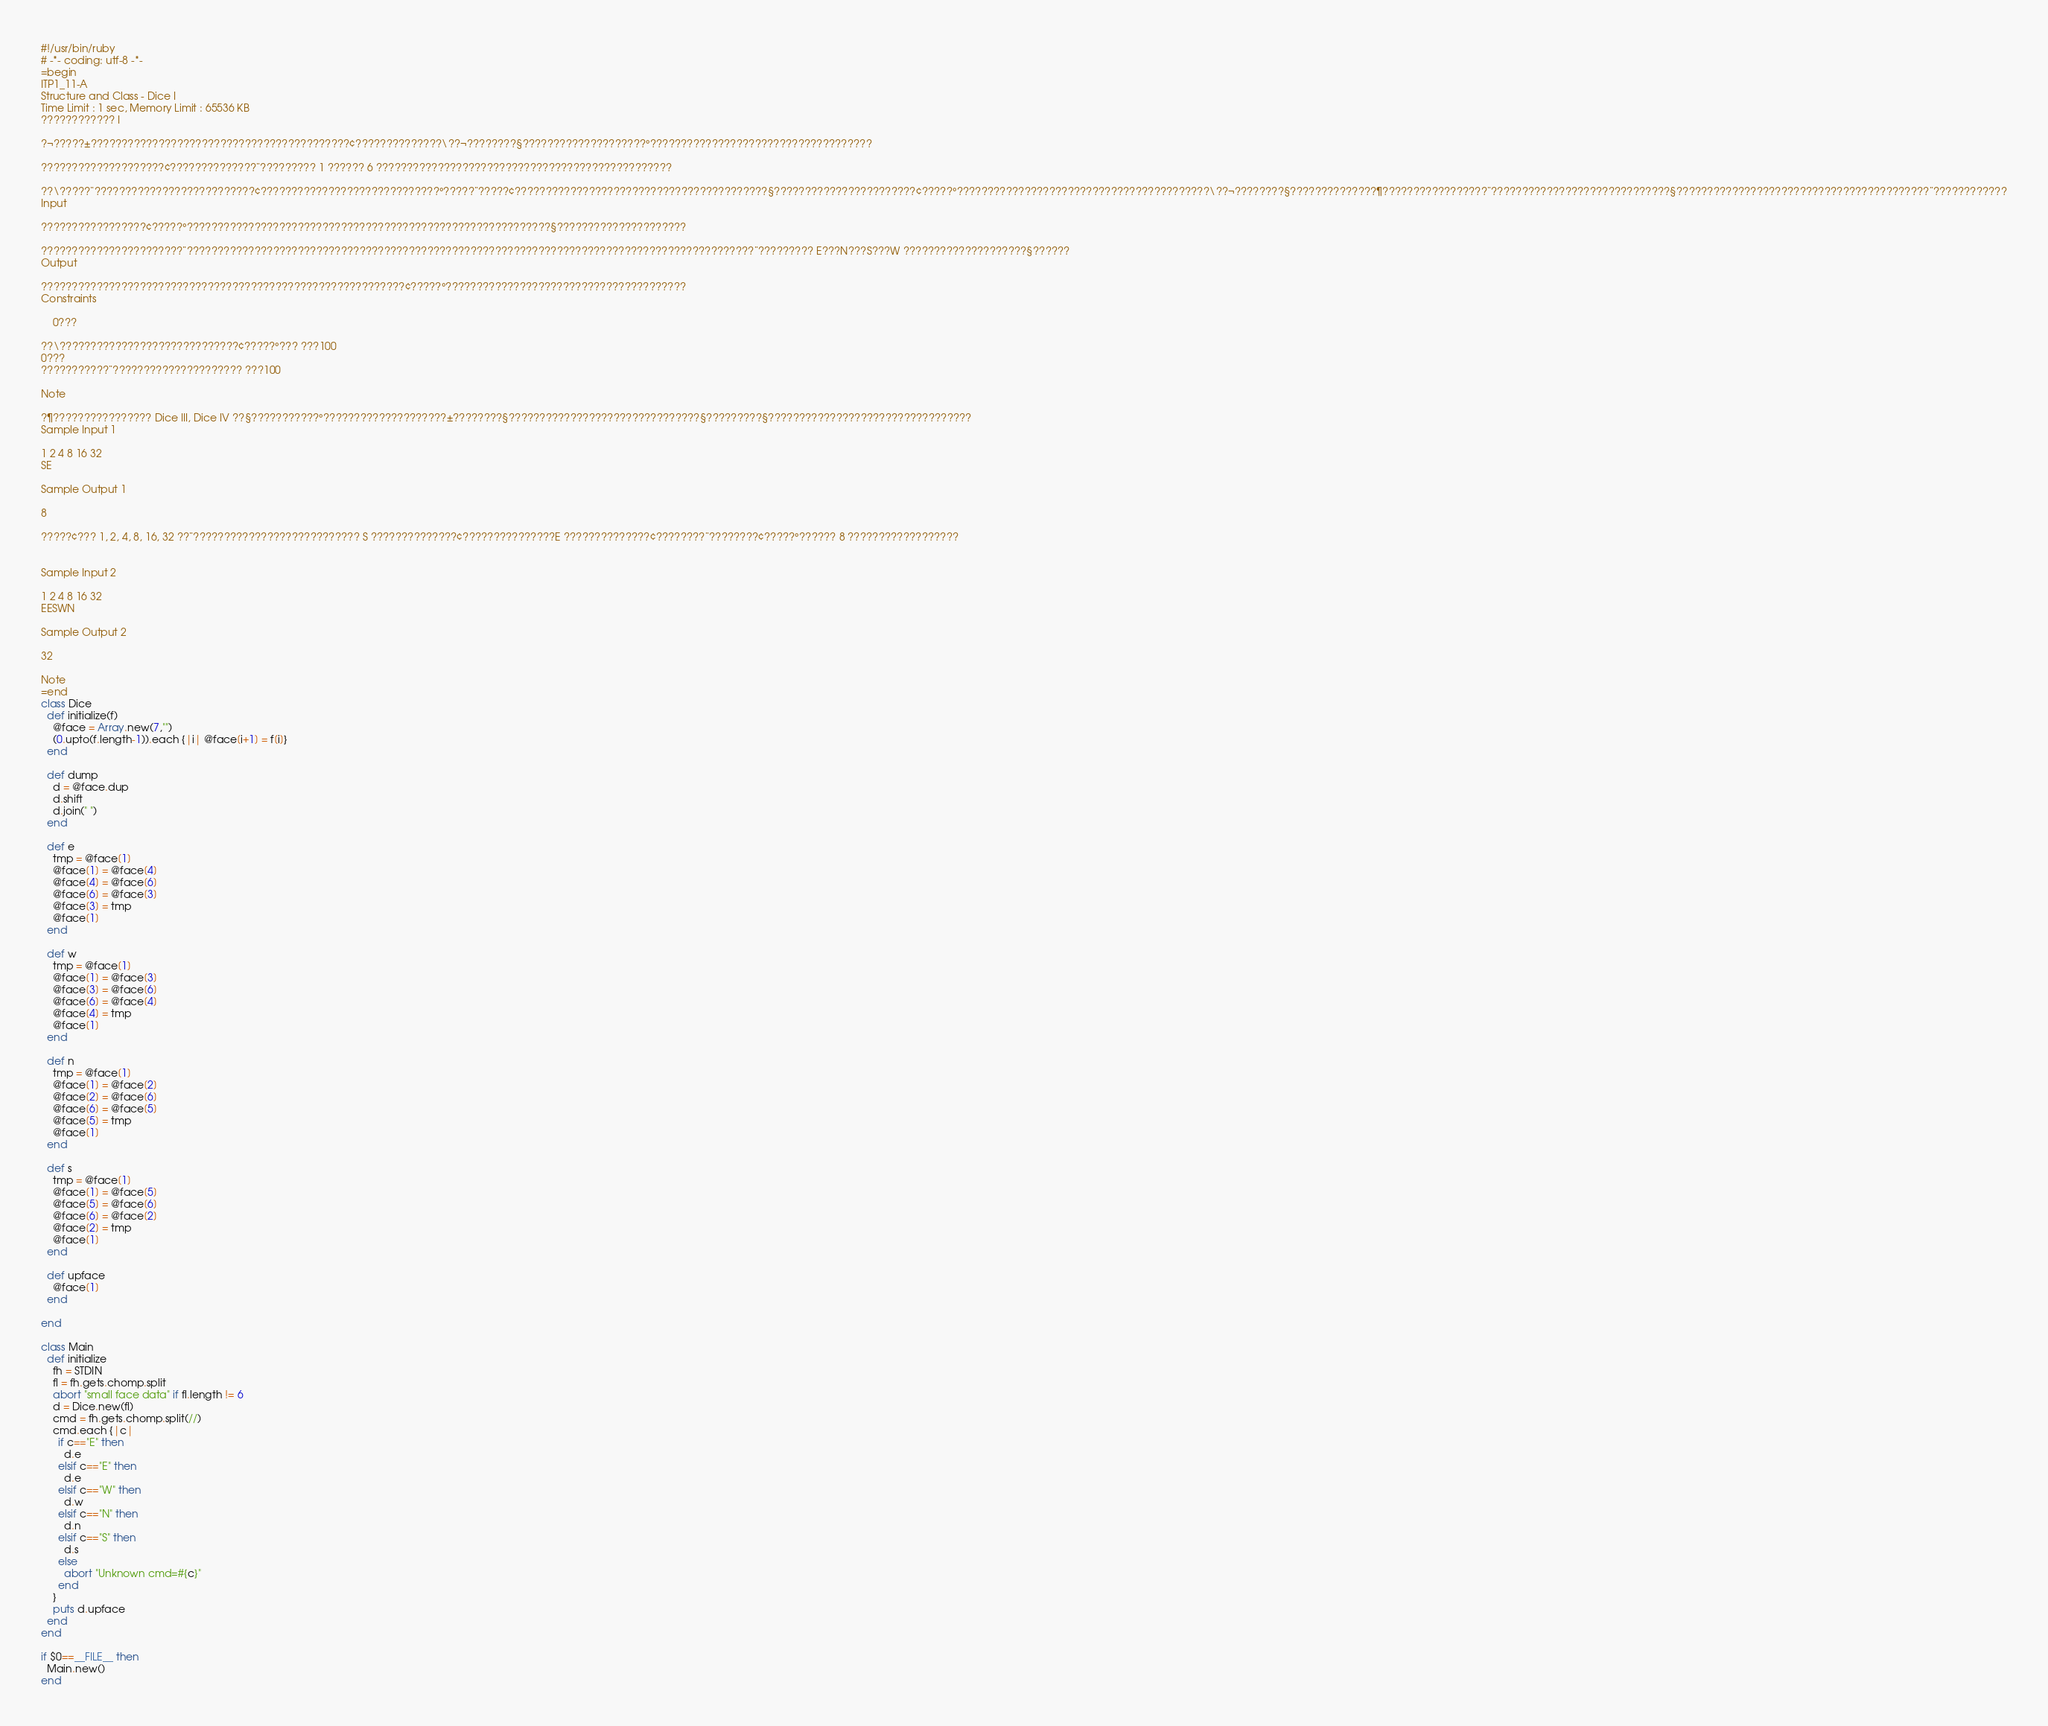<code> <loc_0><loc_0><loc_500><loc_500><_Ruby_>#!/usr/bin/ruby
# -*- coding: utf-8 -*-
=begin
ITP1_11-A
Structure and Class - Dice I
Time Limit : 1 sec, Memory Limit : 65536 KB
???????????? I

?¬?????±??????????????????????????????????????????¢??????????????\??¬????????§????????????????????°????????????????????????????????????

????????????????????¢??????????????¨????????? 1 ?????? 6 ????????????????????????????????????????????????

??\?????¨??????????????????????????¢?????????????????????????????°?????¨?????¢?????????????????????????????????????????§???????????????????????¢?????°?????????????????????????????????????????\??¬????????§??????????????¶?????????????????¨?????????????????????????????§?????????????????????????????????????????¨????????????
Input

?????????????????¢?????°???????????????????????????????????????????????????????????§?????????????????????

???????????????????????¨????????????????????????????????????????????????????????????????????????????????????????????¨????????? E???N???S???W ????????????????????§??????
Output

???????????????????????????????????????????????????????????¢?????°???????????????????????????????????????
Constraints

    0???

??\?????????????????????????????¢?????°??? ???100
0???
???????????¨????????????????????? ???100

Note

?¶???????????????? Dice III, Dice IV ??§???????????°????????????????????±????????§???????????????????????????????§?????????§?????????????????????????????????
Sample Input 1

1 2 4 8 16 32
SE

Sample Output 1

8

?????¢??? 1, 2, 4, 8, 16, 32 ??¨??????????????????????????? S ??????????????¢???????????????E ??????????????¢????????¨????????¢?????°?????? 8 ??????????????????


Sample Input 2

1 2 4 8 16 32
EESWN

Sample Output 2

32

Note
=end
class Dice
  def initialize(f)
    @face = Array.new(7,"")
    (0.upto(f.length-1)).each {|i| @face[i+1] = f[i]} 
  end

  def dump
    d = @face.dup
    d.shift
    d.join(" ")
  end

  def e
    tmp = @face[1] 
    @face[1] = @face[4]
    @face[4] = @face[6]
    @face[6] = @face[3] 
    @face[3] = tmp
    @face[1]
  end

  def w
    tmp = @face[1] 
    @face[1] = @face[3]
    @face[3] = @face[6]
    @face[6] = @face[4]
    @face[4] = tmp
    @face[1]
  end

  def n
    tmp = @face[1] 
    @face[1] = @face[2]
    @face[2] = @face[6]
    @face[6] = @face[5]
    @face[5] = tmp
    @face[1]
  end

  def s
    tmp = @face[1] 
    @face[1] = @face[5]
    @face[5] = @face[6]
    @face[6] = @face[2]
    @face[2] = tmp
    @face[1]
  end

  def upface
    @face[1]
  end

end

class Main
  def initialize
    fh = STDIN
    fl = fh.gets.chomp.split
    abort "small face data" if fl.length != 6
    d = Dice.new(fl)
    cmd = fh.gets.chomp.split(//)
    cmd.each {|c|
      if c=="E" then
        d.e
      elsif c=="E" then
        d.e
      elsif c=="W" then
        d.w
      elsif c=="N" then
        d.n
      elsif c=="S" then
        d.s
      else
        abort "Unknown cmd=#{c}"
      end
    }
    puts d.upface
  end
end

if $0==__FILE__ then
  Main.new()
end</code> 